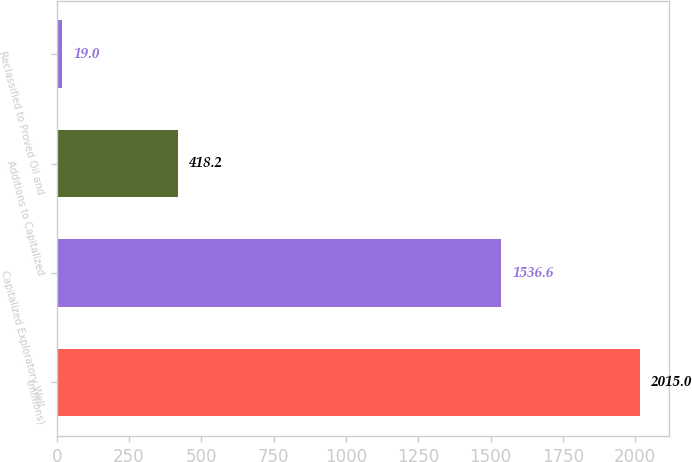<chart> <loc_0><loc_0><loc_500><loc_500><bar_chart><fcel>(millions)<fcel>Capitalized Exploratory Well<fcel>Additions to Capitalized<fcel>Reclassified to Proved Oil and<nl><fcel>2015<fcel>1536.6<fcel>418.2<fcel>19<nl></chart> 